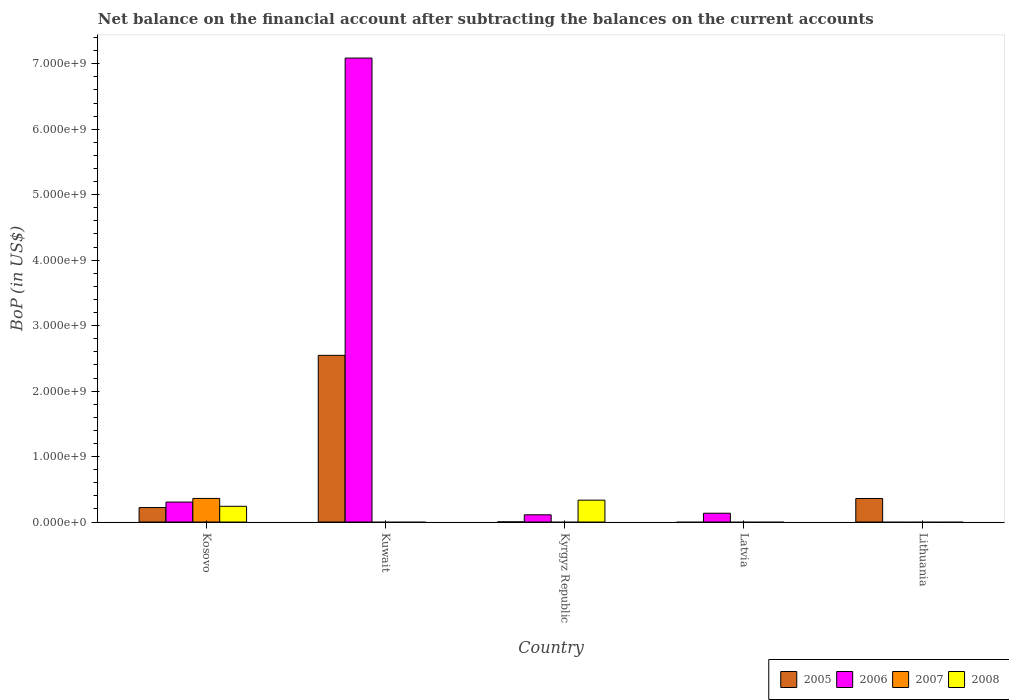Are the number of bars per tick equal to the number of legend labels?
Ensure brevity in your answer.  No. Are the number of bars on each tick of the X-axis equal?
Offer a terse response. No. How many bars are there on the 4th tick from the left?
Your answer should be compact. 1. How many bars are there on the 4th tick from the right?
Keep it short and to the point. 2. What is the label of the 1st group of bars from the left?
Ensure brevity in your answer.  Kosovo. In how many cases, is the number of bars for a given country not equal to the number of legend labels?
Provide a succinct answer. 4. What is the Balance of Payments in 2006 in Kosovo?
Provide a short and direct response. 3.05e+08. Across all countries, what is the maximum Balance of Payments in 2005?
Offer a terse response. 2.55e+09. Across all countries, what is the minimum Balance of Payments in 2007?
Your answer should be very brief. 0. In which country was the Balance of Payments in 2008 maximum?
Provide a succinct answer. Kyrgyz Republic. What is the total Balance of Payments in 2006 in the graph?
Provide a short and direct response. 7.64e+09. What is the difference between the Balance of Payments in 2005 in Kosovo and that in Kyrgyz Republic?
Offer a terse response. 2.19e+08. What is the difference between the Balance of Payments in 2007 in Kuwait and the Balance of Payments in 2005 in Kyrgyz Republic?
Offer a very short reply. -2.12e+06. What is the average Balance of Payments in 2006 per country?
Keep it short and to the point. 1.53e+09. What is the difference between the Balance of Payments of/in 2006 and Balance of Payments of/in 2005 in Kosovo?
Give a very brief answer. 8.37e+07. In how many countries, is the Balance of Payments in 2006 greater than 4600000000 US$?
Provide a short and direct response. 1. What is the ratio of the Balance of Payments in 2005 in Kuwait to that in Kyrgyz Republic?
Give a very brief answer. 1201.81. Is the Balance of Payments in 2006 in Kuwait less than that in Kyrgyz Republic?
Offer a terse response. No. What is the difference between the highest and the second highest Balance of Payments in 2005?
Your answer should be compact. 2.19e+09. What is the difference between the highest and the lowest Balance of Payments in 2007?
Ensure brevity in your answer.  3.60e+08. Is it the case that in every country, the sum of the Balance of Payments in 2007 and Balance of Payments in 2005 is greater than the sum of Balance of Payments in 2006 and Balance of Payments in 2008?
Keep it short and to the point. No. How many bars are there?
Provide a succinct answer. 11. Does the graph contain any zero values?
Your answer should be compact. Yes. Does the graph contain grids?
Your answer should be very brief. No. How many legend labels are there?
Ensure brevity in your answer.  4. How are the legend labels stacked?
Your answer should be compact. Horizontal. What is the title of the graph?
Provide a short and direct response. Net balance on the financial account after subtracting the balances on the current accounts. What is the label or title of the Y-axis?
Offer a very short reply. BoP (in US$). What is the BoP (in US$) in 2005 in Kosovo?
Provide a succinct answer. 2.21e+08. What is the BoP (in US$) of 2006 in Kosovo?
Give a very brief answer. 3.05e+08. What is the BoP (in US$) in 2007 in Kosovo?
Offer a very short reply. 3.60e+08. What is the BoP (in US$) of 2008 in Kosovo?
Provide a succinct answer. 2.41e+08. What is the BoP (in US$) of 2005 in Kuwait?
Your response must be concise. 2.55e+09. What is the BoP (in US$) of 2006 in Kuwait?
Make the answer very short. 7.09e+09. What is the BoP (in US$) of 2007 in Kuwait?
Make the answer very short. 0. What is the BoP (in US$) of 2005 in Kyrgyz Republic?
Offer a very short reply. 2.12e+06. What is the BoP (in US$) of 2006 in Kyrgyz Republic?
Keep it short and to the point. 1.10e+08. What is the BoP (in US$) in 2007 in Kyrgyz Republic?
Provide a short and direct response. 0. What is the BoP (in US$) in 2008 in Kyrgyz Republic?
Offer a terse response. 3.34e+08. What is the BoP (in US$) in 2005 in Latvia?
Your response must be concise. 0. What is the BoP (in US$) of 2006 in Latvia?
Make the answer very short. 1.35e+08. What is the BoP (in US$) of 2007 in Latvia?
Offer a terse response. 0. What is the BoP (in US$) in 2008 in Latvia?
Ensure brevity in your answer.  0. What is the BoP (in US$) of 2005 in Lithuania?
Offer a very short reply. 3.60e+08. What is the BoP (in US$) in 2007 in Lithuania?
Provide a short and direct response. 0. What is the BoP (in US$) of 2008 in Lithuania?
Give a very brief answer. 0. Across all countries, what is the maximum BoP (in US$) of 2005?
Ensure brevity in your answer.  2.55e+09. Across all countries, what is the maximum BoP (in US$) in 2006?
Give a very brief answer. 7.09e+09. Across all countries, what is the maximum BoP (in US$) of 2007?
Ensure brevity in your answer.  3.60e+08. Across all countries, what is the maximum BoP (in US$) of 2008?
Provide a succinct answer. 3.34e+08. Across all countries, what is the minimum BoP (in US$) of 2005?
Give a very brief answer. 0. Across all countries, what is the minimum BoP (in US$) in 2007?
Provide a succinct answer. 0. Across all countries, what is the minimum BoP (in US$) in 2008?
Give a very brief answer. 0. What is the total BoP (in US$) in 2005 in the graph?
Provide a short and direct response. 3.13e+09. What is the total BoP (in US$) of 2006 in the graph?
Make the answer very short. 7.64e+09. What is the total BoP (in US$) of 2007 in the graph?
Provide a succinct answer. 3.60e+08. What is the total BoP (in US$) of 2008 in the graph?
Offer a very short reply. 5.75e+08. What is the difference between the BoP (in US$) in 2005 in Kosovo and that in Kuwait?
Your answer should be very brief. -2.33e+09. What is the difference between the BoP (in US$) in 2006 in Kosovo and that in Kuwait?
Offer a terse response. -6.78e+09. What is the difference between the BoP (in US$) of 2005 in Kosovo and that in Kyrgyz Republic?
Your answer should be very brief. 2.19e+08. What is the difference between the BoP (in US$) of 2006 in Kosovo and that in Kyrgyz Republic?
Your response must be concise. 1.95e+08. What is the difference between the BoP (in US$) in 2008 in Kosovo and that in Kyrgyz Republic?
Provide a succinct answer. -9.37e+07. What is the difference between the BoP (in US$) in 2006 in Kosovo and that in Latvia?
Provide a succinct answer. 1.70e+08. What is the difference between the BoP (in US$) of 2005 in Kosovo and that in Lithuania?
Keep it short and to the point. -1.38e+08. What is the difference between the BoP (in US$) of 2005 in Kuwait and that in Kyrgyz Republic?
Your answer should be compact. 2.54e+09. What is the difference between the BoP (in US$) in 2006 in Kuwait and that in Kyrgyz Republic?
Make the answer very short. 6.98e+09. What is the difference between the BoP (in US$) of 2006 in Kuwait and that in Latvia?
Make the answer very short. 6.95e+09. What is the difference between the BoP (in US$) of 2005 in Kuwait and that in Lithuania?
Ensure brevity in your answer.  2.19e+09. What is the difference between the BoP (in US$) of 2006 in Kyrgyz Republic and that in Latvia?
Give a very brief answer. -2.42e+07. What is the difference between the BoP (in US$) of 2005 in Kyrgyz Republic and that in Lithuania?
Your answer should be compact. -3.57e+08. What is the difference between the BoP (in US$) in 2005 in Kosovo and the BoP (in US$) in 2006 in Kuwait?
Provide a short and direct response. -6.87e+09. What is the difference between the BoP (in US$) in 2005 in Kosovo and the BoP (in US$) in 2006 in Kyrgyz Republic?
Offer a terse response. 1.11e+08. What is the difference between the BoP (in US$) in 2005 in Kosovo and the BoP (in US$) in 2008 in Kyrgyz Republic?
Give a very brief answer. -1.13e+08. What is the difference between the BoP (in US$) in 2006 in Kosovo and the BoP (in US$) in 2008 in Kyrgyz Republic?
Make the answer very short. -2.94e+07. What is the difference between the BoP (in US$) in 2007 in Kosovo and the BoP (in US$) in 2008 in Kyrgyz Republic?
Your response must be concise. 2.61e+07. What is the difference between the BoP (in US$) of 2005 in Kosovo and the BoP (in US$) of 2006 in Latvia?
Keep it short and to the point. 8.66e+07. What is the difference between the BoP (in US$) in 2005 in Kuwait and the BoP (in US$) in 2006 in Kyrgyz Republic?
Ensure brevity in your answer.  2.44e+09. What is the difference between the BoP (in US$) of 2005 in Kuwait and the BoP (in US$) of 2008 in Kyrgyz Republic?
Your answer should be compact. 2.21e+09. What is the difference between the BoP (in US$) in 2006 in Kuwait and the BoP (in US$) in 2008 in Kyrgyz Republic?
Your response must be concise. 6.75e+09. What is the difference between the BoP (in US$) of 2005 in Kuwait and the BoP (in US$) of 2006 in Latvia?
Offer a very short reply. 2.41e+09. What is the difference between the BoP (in US$) of 2005 in Kyrgyz Republic and the BoP (in US$) of 2006 in Latvia?
Offer a very short reply. -1.32e+08. What is the average BoP (in US$) of 2005 per country?
Ensure brevity in your answer.  6.26e+08. What is the average BoP (in US$) in 2006 per country?
Provide a succinct answer. 1.53e+09. What is the average BoP (in US$) in 2007 per country?
Your answer should be compact. 7.21e+07. What is the average BoP (in US$) of 2008 per country?
Keep it short and to the point. 1.15e+08. What is the difference between the BoP (in US$) in 2005 and BoP (in US$) in 2006 in Kosovo?
Offer a very short reply. -8.37e+07. What is the difference between the BoP (in US$) in 2005 and BoP (in US$) in 2007 in Kosovo?
Provide a short and direct response. -1.39e+08. What is the difference between the BoP (in US$) of 2005 and BoP (in US$) of 2008 in Kosovo?
Ensure brevity in your answer.  -1.93e+07. What is the difference between the BoP (in US$) in 2006 and BoP (in US$) in 2007 in Kosovo?
Ensure brevity in your answer.  -5.55e+07. What is the difference between the BoP (in US$) in 2006 and BoP (in US$) in 2008 in Kosovo?
Give a very brief answer. 6.44e+07. What is the difference between the BoP (in US$) of 2007 and BoP (in US$) of 2008 in Kosovo?
Your answer should be very brief. 1.20e+08. What is the difference between the BoP (in US$) in 2005 and BoP (in US$) in 2006 in Kuwait?
Give a very brief answer. -4.54e+09. What is the difference between the BoP (in US$) of 2005 and BoP (in US$) of 2006 in Kyrgyz Republic?
Keep it short and to the point. -1.08e+08. What is the difference between the BoP (in US$) of 2005 and BoP (in US$) of 2008 in Kyrgyz Republic?
Offer a very short reply. -3.32e+08. What is the difference between the BoP (in US$) of 2006 and BoP (in US$) of 2008 in Kyrgyz Republic?
Your answer should be very brief. -2.24e+08. What is the ratio of the BoP (in US$) of 2005 in Kosovo to that in Kuwait?
Make the answer very short. 0.09. What is the ratio of the BoP (in US$) of 2006 in Kosovo to that in Kuwait?
Offer a terse response. 0.04. What is the ratio of the BoP (in US$) in 2005 in Kosovo to that in Kyrgyz Republic?
Your response must be concise. 104.42. What is the ratio of the BoP (in US$) of 2006 in Kosovo to that in Kyrgyz Republic?
Offer a terse response. 2.76. What is the ratio of the BoP (in US$) of 2008 in Kosovo to that in Kyrgyz Republic?
Provide a short and direct response. 0.72. What is the ratio of the BoP (in US$) in 2006 in Kosovo to that in Latvia?
Your response must be concise. 2.27. What is the ratio of the BoP (in US$) in 2005 in Kosovo to that in Lithuania?
Make the answer very short. 0.62. What is the ratio of the BoP (in US$) in 2005 in Kuwait to that in Kyrgyz Republic?
Your answer should be compact. 1201.81. What is the ratio of the BoP (in US$) in 2006 in Kuwait to that in Kyrgyz Republic?
Provide a short and direct response. 64.19. What is the ratio of the BoP (in US$) of 2006 in Kuwait to that in Latvia?
Make the answer very short. 52.65. What is the ratio of the BoP (in US$) of 2005 in Kuwait to that in Lithuania?
Your response must be concise. 7.08. What is the ratio of the BoP (in US$) in 2006 in Kyrgyz Republic to that in Latvia?
Provide a succinct answer. 0.82. What is the ratio of the BoP (in US$) of 2005 in Kyrgyz Republic to that in Lithuania?
Your answer should be compact. 0.01. What is the difference between the highest and the second highest BoP (in US$) in 2005?
Your answer should be compact. 2.19e+09. What is the difference between the highest and the second highest BoP (in US$) of 2006?
Provide a short and direct response. 6.78e+09. What is the difference between the highest and the lowest BoP (in US$) in 2005?
Your response must be concise. 2.55e+09. What is the difference between the highest and the lowest BoP (in US$) in 2006?
Your answer should be compact. 7.09e+09. What is the difference between the highest and the lowest BoP (in US$) of 2007?
Your answer should be compact. 3.60e+08. What is the difference between the highest and the lowest BoP (in US$) of 2008?
Make the answer very short. 3.34e+08. 